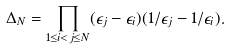Convert formula to latex. <formula><loc_0><loc_0><loc_500><loc_500>\Delta _ { N } = \prod _ { 1 \leq i < j \leq N } ( \epsilon _ { j } - \epsilon _ { i } ) ( 1 / \epsilon _ { j } - 1 / \epsilon _ { i } ) .</formula> 